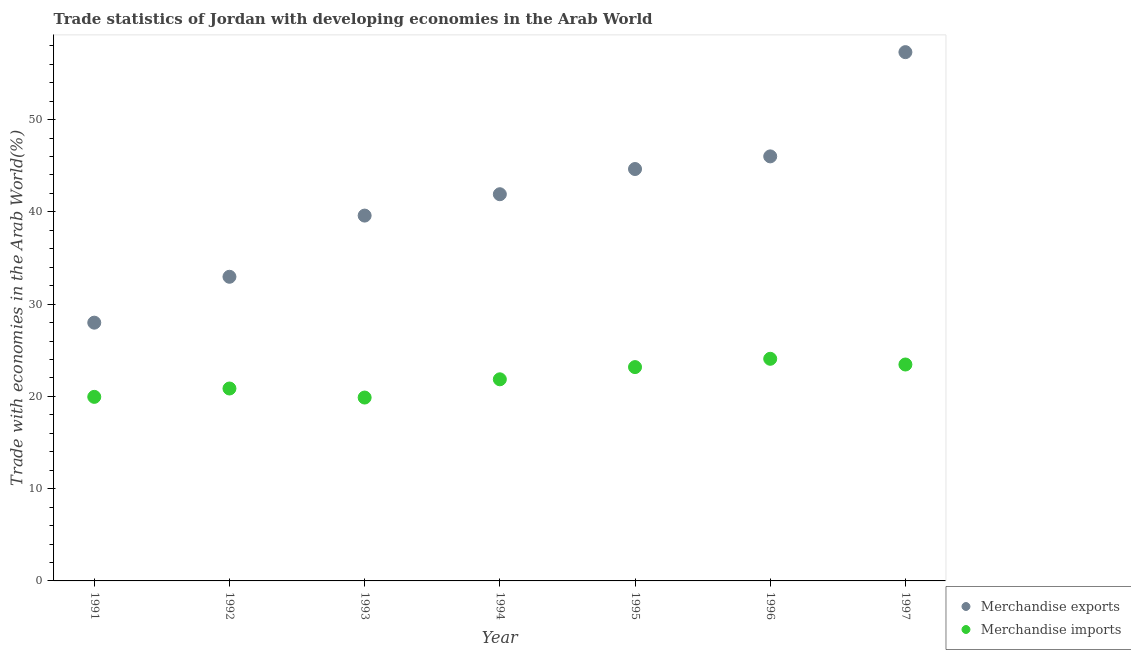How many different coloured dotlines are there?
Give a very brief answer. 2. What is the merchandise imports in 1997?
Make the answer very short. 23.46. Across all years, what is the maximum merchandise exports?
Ensure brevity in your answer.  57.31. Across all years, what is the minimum merchandise imports?
Give a very brief answer. 19.87. In which year was the merchandise exports minimum?
Your response must be concise. 1991. What is the total merchandise exports in the graph?
Give a very brief answer. 290.43. What is the difference between the merchandise exports in 1993 and that in 1997?
Your response must be concise. -17.71. What is the difference between the merchandise imports in 1997 and the merchandise exports in 1993?
Keep it short and to the point. -16.14. What is the average merchandise exports per year?
Offer a terse response. 41.49. In the year 1992, what is the difference between the merchandise imports and merchandise exports?
Provide a short and direct response. -12.11. In how many years, is the merchandise imports greater than 18 %?
Offer a very short reply. 7. What is the ratio of the merchandise imports in 1991 to that in 1994?
Offer a very short reply. 0.91. Is the difference between the merchandise imports in 1992 and 1997 greater than the difference between the merchandise exports in 1992 and 1997?
Your response must be concise. Yes. What is the difference between the highest and the second highest merchandise imports?
Make the answer very short. 0.62. What is the difference between the highest and the lowest merchandise imports?
Offer a terse response. 4.2. Is the sum of the merchandise imports in 1991 and 1992 greater than the maximum merchandise exports across all years?
Give a very brief answer. No. Does the merchandise exports monotonically increase over the years?
Ensure brevity in your answer.  Yes. Is the merchandise exports strictly greater than the merchandise imports over the years?
Offer a very short reply. Yes. How many years are there in the graph?
Your answer should be very brief. 7. What is the difference between two consecutive major ticks on the Y-axis?
Provide a short and direct response. 10. Are the values on the major ticks of Y-axis written in scientific E-notation?
Make the answer very short. No. Does the graph contain any zero values?
Offer a very short reply. No. Does the graph contain grids?
Give a very brief answer. No. Where does the legend appear in the graph?
Your response must be concise. Bottom right. How are the legend labels stacked?
Offer a very short reply. Vertical. What is the title of the graph?
Give a very brief answer. Trade statistics of Jordan with developing economies in the Arab World. What is the label or title of the Y-axis?
Make the answer very short. Trade with economies in the Arab World(%). What is the Trade with economies in the Arab World(%) in Merchandise exports in 1991?
Your answer should be compact. 27.99. What is the Trade with economies in the Arab World(%) in Merchandise imports in 1991?
Make the answer very short. 19.95. What is the Trade with economies in the Arab World(%) in Merchandise exports in 1992?
Your answer should be very brief. 32.96. What is the Trade with economies in the Arab World(%) in Merchandise imports in 1992?
Your response must be concise. 20.85. What is the Trade with economies in the Arab World(%) in Merchandise exports in 1993?
Your answer should be very brief. 39.6. What is the Trade with economies in the Arab World(%) in Merchandise imports in 1993?
Offer a terse response. 19.87. What is the Trade with economies in the Arab World(%) in Merchandise exports in 1994?
Your answer should be compact. 41.91. What is the Trade with economies in the Arab World(%) of Merchandise imports in 1994?
Give a very brief answer. 21.85. What is the Trade with economies in the Arab World(%) in Merchandise exports in 1995?
Make the answer very short. 44.64. What is the Trade with economies in the Arab World(%) of Merchandise imports in 1995?
Your answer should be very brief. 23.17. What is the Trade with economies in the Arab World(%) in Merchandise exports in 1996?
Ensure brevity in your answer.  46.01. What is the Trade with economies in the Arab World(%) in Merchandise imports in 1996?
Make the answer very short. 24.07. What is the Trade with economies in the Arab World(%) in Merchandise exports in 1997?
Make the answer very short. 57.31. What is the Trade with economies in the Arab World(%) of Merchandise imports in 1997?
Offer a terse response. 23.46. Across all years, what is the maximum Trade with economies in the Arab World(%) of Merchandise exports?
Provide a succinct answer. 57.31. Across all years, what is the maximum Trade with economies in the Arab World(%) in Merchandise imports?
Ensure brevity in your answer.  24.07. Across all years, what is the minimum Trade with economies in the Arab World(%) of Merchandise exports?
Your response must be concise. 27.99. Across all years, what is the minimum Trade with economies in the Arab World(%) in Merchandise imports?
Ensure brevity in your answer.  19.87. What is the total Trade with economies in the Arab World(%) in Merchandise exports in the graph?
Offer a very short reply. 290.43. What is the total Trade with economies in the Arab World(%) of Merchandise imports in the graph?
Offer a terse response. 153.23. What is the difference between the Trade with economies in the Arab World(%) of Merchandise exports in 1991 and that in 1992?
Ensure brevity in your answer.  -4.97. What is the difference between the Trade with economies in the Arab World(%) of Merchandise imports in 1991 and that in 1992?
Your answer should be compact. -0.91. What is the difference between the Trade with economies in the Arab World(%) of Merchandise exports in 1991 and that in 1993?
Your answer should be compact. -11.6. What is the difference between the Trade with economies in the Arab World(%) of Merchandise imports in 1991 and that in 1993?
Give a very brief answer. 0.07. What is the difference between the Trade with economies in the Arab World(%) of Merchandise exports in 1991 and that in 1994?
Ensure brevity in your answer.  -13.92. What is the difference between the Trade with economies in the Arab World(%) of Merchandise imports in 1991 and that in 1994?
Provide a short and direct response. -1.9. What is the difference between the Trade with economies in the Arab World(%) in Merchandise exports in 1991 and that in 1995?
Your answer should be compact. -16.65. What is the difference between the Trade with economies in the Arab World(%) in Merchandise imports in 1991 and that in 1995?
Offer a terse response. -3.23. What is the difference between the Trade with economies in the Arab World(%) in Merchandise exports in 1991 and that in 1996?
Ensure brevity in your answer.  -18.02. What is the difference between the Trade with economies in the Arab World(%) in Merchandise imports in 1991 and that in 1996?
Offer a terse response. -4.13. What is the difference between the Trade with economies in the Arab World(%) in Merchandise exports in 1991 and that in 1997?
Give a very brief answer. -29.32. What is the difference between the Trade with economies in the Arab World(%) of Merchandise imports in 1991 and that in 1997?
Give a very brief answer. -3.51. What is the difference between the Trade with economies in the Arab World(%) of Merchandise exports in 1992 and that in 1993?
Make the answer very short. -6.63. What is the difference between the Trade with economies in the Arab World(%) in Merchandise imports in 1992 and that in 1993?
Offer a terse response. 0.98. What is the difference between the Trade with economies in the Arab World(%) of Merchandise exports in 1992 and that in 1994?
Offer a terse response. -8.95. What is the difference between the Trade with economies in the Arab World(%) in Merchandise imports in 1992 and that in 1994?
Keep it short and to the point. -1. What is the difference between the Trade with economies in the Arab World(%) in Merchandise exports in 1992 and that in 1995?
Ensure brevity in your answer.  -11.68. What is the difference between the Trade with economies in the Arab World(%) of Merchandise imports in 1992 and that in 1995?
Offer a very short reply. -2.32. What is the difference between the Trade with economies in the Arab World(%) in Merchandise exports in 1992 and that in 1996?
Offer a terse response. -13.05. What is the difference between the Trade with economies in the Arab World(%) in Merchandise imports in 1992 and that in 1996?
Your response must be concise. -3.22. What is the difference between the Trade with economies in the Arab World(%) in Merchandise exports in 1992 and that in 1997?
Give a very brief answer. -24.35. What is the difference between the Trade with economies in the Arab World(%) in Merchandise imports in 1992 and that in 1997?
Provide a succinct answer. -2.6. What is the difference between the Trade with economies in the Arab World(%) of Merchandise exports in 1993 and that in 1994?
Offer a terse response. -2.32. What is the difference between the Trade with economies in the Arab World(%) of Merchandise imports in 1993 and that in 1994?
Ensure brevity in your answer.  -1.98. What is the difference between the Trade with economies in the Arab World(%) in Merchandise exports in 1993 and that in 1995?
Make the answer very short. -5.05. What is the difference between the Trade with economies in the Arab World(%) of Merchandise imports in 1993 and that in 1995?
Make the answer very short. -3.3. What is the difference between the Trade with economies in the Arab World(%) of Merchandise exports in 1993 and that in 1996?
Offer a very short reply. -6.42. What is the difference between the Trade with economies in the Arab World(%) of Merchandise imports in 1993 and that in 1996?
Provide a short and direct response. -4.2. What is the difference between the Trade with economies in the Arab World(%) in Merchandise exports in 1993 and that in 1997?
Your answer should be very brief. -17.71. What is the difference between the Trade with economies in the Arab World(%) of Merchandise imports in 1993 and that in 1997?
Make the answer very short. -3.58. What is the difference between the Trade with economies in the Arab World(%) of Merchandise exports in 1994 and that in 1995?
Give a very brief answer. -2.73. What is the difference between the Trade with economies in the Arab World(%) of Merchandise imports in 1994 and that in 1995?
Your response must be concise. -1.32. What is the difference between the Trade with economies in the Arab World(%) in Merchandise exports in 1994 and that in 1996?
Give a very brief answer. -4.1. What is the difference between the Trade with economies in the Arab World(%) in Merchandise imports in 1994 and that in 1996?
Your response must be concise. -2.22. What is the difference between the Trade with economies in the Arab World(%) of Merchandise exports in 1994 and that in 1997?
Keep it short and to the point. -15.4. What is the difference between the Trade with economies in the Arab World(%) of Merchandise imports in 1994 and that in 1997?
Your answer should be compact. -1.6. What is the difference between the Trade with economies in the Arab World(%) of Merchandise exports in 1995 and that in 1996?
Your answer should be compact. -1.37. What is the difference between the Trade with economies in the Arab World(%) of Merchandise imports in 1995 and that in 1996?
Offer a terse response. -0.9. What is the difference between the Trade with economies in the Arab World(%) of Merchandise exports in 1995 and that in 1997?
Ensure brevity in your answer.  -12.67. What is the difference between the Trade with economies in the Arab World(%) in Merchandise imports in 1995 and that in 1997?
Keep it short and to the point. -0.28. What is the difference between the Trade with economies in the Arab World(%) in Merchandise exports in 1996 and that in 1997?
Keep it short and to the point. -11.3. What is the difference between the Trade with economies in the Arab World(%) in Merchandise imports in 1996 and that in 1997?
Your answer should be compact. 0.62. What is the difference between the Trade with economies in the Arab World(%) in Merchandise exports in 1991 and the Trade with economies in the Arab World(%) in Merchandise imports in 1992?
Your answer should be very brief. 7.14. What is the difference between the Trade with economies in the Arab World(%) in Merchandise exports in 1991 and the Trade with economies in the Arab World(%) in Merchandise imports in 1993?
Your answer should be very brief. 8.12. What is the difference between the Trade with economies in the Arab World(%) in Merchandise exports in 1991 and the Trade with economies in the Arab World(%) in Merchandise imports in 1994?
Your answer should be very brief. 6.14. What is the difference between the Trade with economies in the Arab World(%) in Merchandise exports in 1991 and the Trade with economies in the Arab World(%) in Merchandise imports in 1995?
Your answer should be very brief. 4.82. What is the difference between the Trade with economies in the Arab World(%) of Merchandise exports in 1991 and the Trade with economies in the Arab World(%) of Merchandise imports in 1996?
Offer a terse response. 3.92. What is the difference between the Trade with economies in the Arab World(%) of Merchandise exports in 1991 and the Trade with economies in the Arab World(%) of Merchandise imports in 1997?
Provide a succinct answer. 4.54. What is the difference between the Trade with economies in the Arab World(%) of Merchandise exports in 1992 and the Trade with economies in the Arab World(%) of Merchandise imports in 1993?
Keep it short and to the point. 13.09. What is the difference between the Trade with economies in the Arab World(%) of Merchandise exports in 1992 and the Trade with economies in the Arab World(%) of Merchandise imports in 1994?
Give a very brief answer. 11.11. What is the difference between the Trade with economies in the Arab World(%) of Merchandise exports in 1992 and the Trade with economies in the Arab World(%) of Merchandise imports in 1995?
Offer a terse response. 9.79. What is the difference between the Trade with economies in the Arab World(%) in Merchandise exports in 1992 and the Trade with economies in the Arab World(%) in Merchandise imports in 1996?
Offer a very short reply. 8.89. What is the difference between the Trade with economies in the Arab World(%) of Merchandise exports in 1992 and the Trade with economies in the Arab World(%) of Merchandise imports in 1997?
Your response must be concise. 9.51. What is the difference between the Trade with economies in the Arab World(%) in Merchandise exports in 1993 and the Trade with economies in the Arab World(%) in Merchandise imports in 1994?
Your answer should be very brief. 17.74. What is the difference between the Trade with economies in the Arab World(%) of Merchandise exports in 1993 and the Trade with economies in the Arab World(%) of Merchandise imports in 1995?
Provide a short and direct response. 16.42. What is the difference between the Trade with economies in the Arab World(%) of Merchandise exports in 1993 and the Trade with economies in the Arab World(%) of Merchandise imports in 1996?
Give a very brief answer. 15.52. What is the difference between the Trade with economies in the Arab World(%) in Merchandise exports in 1993 and the Trade with economies in the Arab World(%) in Merchandise imports in 1997?
Your response must be concise. 16.14. What is the difference between the Trade with economies in the Arab World(%) in Merchandise exports in 1994 and the Trade with economies in the Arab World(%) in Merchandise imports in 1995?
Make the answer very short. 18.74. What is the difference between the Trade with economies in the Arab World(%) in Merchandise exports in 1994 and the Trade with economies in the Arab World(%) in Merchandise imports in 1996?
Provide a short and direct response. 17.84. What is the difference between the Trade with economies in the Arab World(%) of Merchandise exports in 1994 and the Trade with economies in the Arab World(%) of Merchandise imports in 1997?
Your answer should be compact. 18.45. What is the difference between the Trade with economies in the Arab World(%) in Merchandise exports in 1995 and the Trade with economies in the Arab World(%) in Merchandise imports in 1996?
Your answer should be compact. 20.57. What is the difference between the Trade with economies in the Arab World(%) in Merchandise exports in 1995 and the Trade with economies in the Arab World(%) in Merchandise imports in 1997?
Offer a terse response. 21.19. What is the difference between the Trade with economies in the Arab World(%) of Merchandise exports in 1996 and the Trade with economies in the Arab World(%) of Merchandise imports in 1997?
Your answer should be compact. 22.56. What is the average Trade with economies in the Arab World(%) in Merchandise exports per year?
Make the answer very short. 41.49. What is the average Trade with economies in the Arab World(%) in Merchandise imports per year?
Offer a terse response. 21.89. In the year 1991, what is the difference between the Trade with economies in the Arab World(%) in Merchandise exports and Trade with economies in the Arab World(%) in Merchandise imports?
Your response must be concise. 8.04. In the year 1992, what is the difference between the Trade with economies in the Arab World(%) of Merchandise exports and Trade with economies in the Arab World(%) of Merchandise imports?
Offer a terse response. 12.11. In the year 1993, what is the difference between the Trade with economies in the Arab World(%) of Merchandise exports and Trade with economies in the Arab World(%) of Merchandise imports?
Give a very brief answer. 19.72. In the year 1994, what is the difference between the Trade with economies in the Arab World(%) in Merchandise exports and Trade with economies in the Arab World(%) in Merchandise imports?
Offer a terse response. 20.06. In the year 1995, what is the difference between the Trade with economies in the Arab World(%) of Merchandise exports and Trade with economies in the Arab World(%) of Merchandise imports?
Your response must be concise. 21.47. In the year 1996, what is the difference between the Trade with economies in the Arab World(%) of Merchandise exports and Trade with economies in the Arab World(%) of Merchandise imports?
Provide a short and direct response. 21.94. In the year 1997, what is the difference between the Trade with economies in the Arab World(%) of Merchandise exports and Trade with economies in the Arab World(%) of Merchandise imports?
Provide a succinct answer. 33.85. What is the ratio of the Trade with economies in the Arab World(%) in Merchandise exports in 1991 to that in 1992?
Your response must be concise. 0.85. What is the ratio of the Trade with economies in the Arab World(%) of Merchandise imports in 1991 to that in 1992?
Make the answer very short. 0.96. What is the ratio of the Trade with economies in the Arab World(%) of Merchandise exports in 1991 to that in 1993?
Ensure brevity in your answer.  0.71. What is the ratio of the Trade with economies in the Arab World(%) of Merchandise exports in 1991 to that in 1994?
Provide a short and direct response. 0.67. What is the ratio of the Trade with economies in the Arab World(%) of Merchandise imports in 1991 to that in 1994?
Make the answer very short. 0.91. What is the ratio of the Trade with economies in the Arab World(%) of Merchandise exports in 1991 to that in 1995?
Offer a very short reply. 0.63. What is the ratio of the Trade with economies in the Arab World(%) in Merchandise imports in 1991 to that in 1995?
Provide a short and direct response. 0.86. What is the ratio of the Trade with economies in the Arab World(%) of Merchandise exports in 1991 to that in 1996?
Provide a succinct answer. 0.61. What is the ratio of the Trade with economies in the Arab World(%) of Merchandise imports in 1991 to that in 1996?
Your answer should be very brief. 0.83. What is the ratio of the Trade with economies in the Arab World(%) of Merchandise exports in 1991 to that in 1997?
Make the answer very short. 0.49. What is the ratio of the Trade with economies in the Arab World(%) of Merchandise imports in 1991 to that in 1997?
Your answer should be compact. 0.85. What is the ratio of the Trade with economies in the Arab World(%) of Merchandise exports in 1992 to that in 1993?
Keep it short and to the point. 0.83. What is the ratio of the Trade with economies in the Arab World(%) in Merchandise imports in 1992 to that in 1993?
Your answer should be compact. 1.05. What is the ratio of the Trade with economies in the Arab World(%) of Merchandise exports in 1992 to that in 1994?
Offer a very short reply. 0.79. What is the ratio of the Trade with economies in the Arab World(%) of Merchandise imports in 1992 to that in 1994?
Make the answer very short. 0.95. What is the ratio of the Trade with economies in the Arab World(%) of Merchandise exports in 1992 to that in 1995?
Make the answer very short. 0.74. What is the ratio of the Trade with economies in the Arab World(%) in Merchandise imports in 1992 to that in 1995?
Make the answer very short. 0.9. What is the ratio of the Trade with economies in the Arab World(%) in Merchandise exports in 1992 to that in 1996?
Your answer should be very brief. 0.72. What is the ratio of the Trade with economies in the Arab World(%) of Merchandise imports in 1992 to that in 1996?
Offer a very short reply. 0.87. What is the ratio of the Trade with economies in the Arab World(%) of Merchandise exports in 1992 to that in 1997?
Make the answer very short. 0.58. What is the ratio of the Trade with economies in the Arab World(%) in Merchandise imports in 1992 to that in 1997?
Give a very brief answer. 0.89. What is the ratio of the Trade with economies in the Arab World(%) in Merchandise exports in 1993 to that in 1994?
Give a very brief answer. 0.94. What is the ratio of the Trade with economies in the Arab World(%) in Merchandise imports in 1993 to that in 1994?
Give a very brief answer. 0.91. What is the ratio of the Trade with economies in the Arab World(%) in Merchandise exports in 1993 to that in 1995?
Provide a succinct answer. 0.89. What is the ratio of the Trade with economies in the Arab World(%) of Merchandise imports in 1993 to that in 1995?
Your response must be concise. 0.86. What is the ratio of the Trade with economies in the Arab World(%) in Merchandise exports in 1993 to that in 1996?
Offer a terse response. 0.86. What is the ratio of the Trade with economies in the Arab World(%) of Merchandise imports in 1993 to that in 1996?
Ensure brevity in your answer.  0.83. What is the ratio of the Trade with economies in the Arab World(%) of Merchandise exports in 1993 to that in 1997?
Give a very brief answer. 0.69. What is the ratio of the Trade with economies in the Arab World(%) of Merchandise imports in 1993 to that in 1997?
Provide a short and direct response. 0.85. What is the ratio of the Trade with economies in the Arab World(%) of Merchandise exports in 1994 to that in 1995?
Ensure brevity in your answer.  0.94. What is the ratio of the Trade with economies in the Arab World(%) of Merchandise imports in 1994 to that in 1995?
Offer a terse response. 0.94. What is the ratio of the Trade with economies in the Arab World(%) of Merchandise exports in 1994 to that in 1996?
Provide a succinct answer. 0.91. What is the ratio of the Trade with economies in the Arab World(%) in Merchandise imports in 1994 to that in 1996?
Ensure brevity in your answer.  0.91. What is the ratio of the Trade with economies in the Arab World(%) in Merchandise exports in 1994 to that in 1997?
Your answer should be compact. 0.73. What is the ratio of the Trade with economies in the Arab World(%) in Merchandise imports in 1994 to that in 1997?
Your answer should be very brief. 0.93. What is the ratio of the Trade with economies in the Arab World(%) in Merchandise exports in 1995 to that in 1996?
Give a very brief answer. 0.97. What is the ratio of the Trade with economies in the Arab World(%) in Merchandise imports in 1995 to that in 1996?
Your response must be concise. 0.96. What is the ratio of the Trade with economies in the Arab World(%) in Merchandise exports in 1995 to that in 1997?
Provide a short and direct response. 0.78. What is the ratio of the Trade with economies in the Arab World(%) in Merchandise exports in 1996 to that in 1997?
Your answer should be compact. 0.8. What is the ratio of the Trade with economies in the Arab World(%) of Merchandise imports in 1996 to that in 1997?
Provide a succinct answer. 1.03. What is the difference between the highest and the second highest Trade with economies in the Arab World(%) of Merchandise exports?
Keep it short and to the point. 11.3. What is the difference between the highest and the second highest Trade with economies in the Arab World(%) of Merchandise imports?
Offer a terse response. 0.62. What is the difference between the highest and the lowest Trade with economies in the Arab World(%) of Merchandise exports?
Provide a succinct answer. 29.32. What is the difference between the highest and the lowest Trade with economies in the Arab World(%) in Merchandise imports?
Your response must be concise. 4.2. 